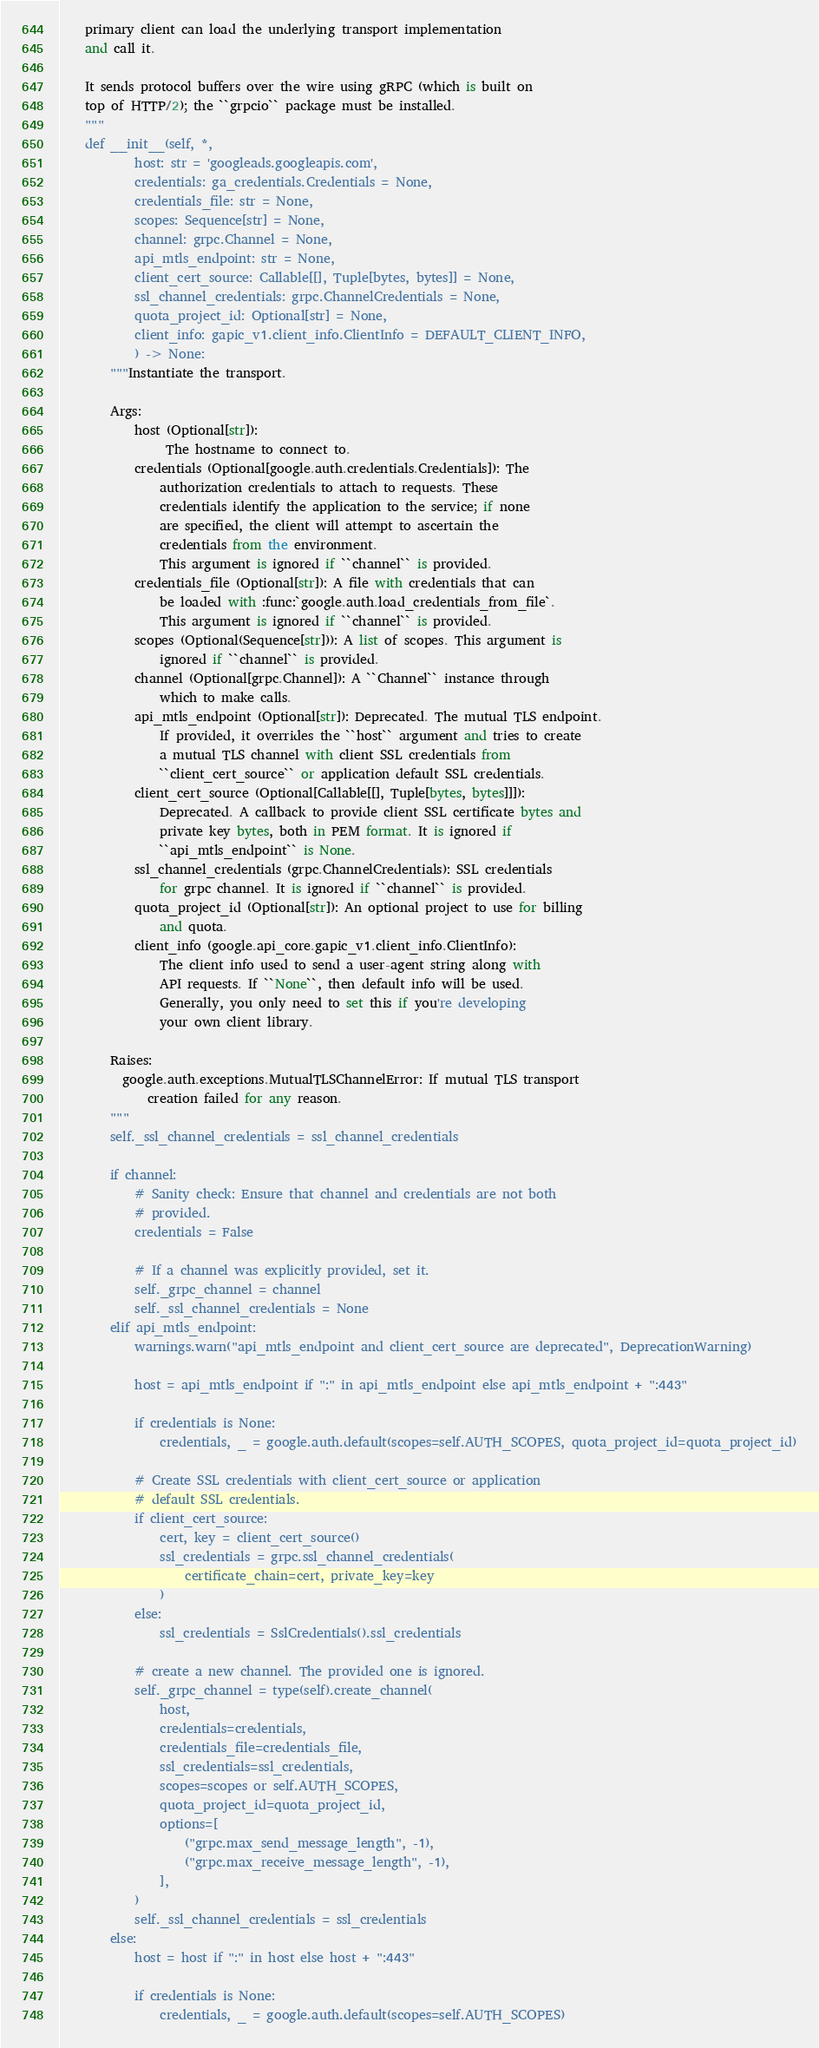Convert code to text. <code><loc_0><loc_0><loc_500><loc_500><_Python_>    primary client can load the underlying transport implementation
    and call it.

    It sends protocol buffers over the wire using gRPC (which is built on
    top of HTTP/2); the ``grpcio`` package must be installed.
    """
    def __init__(self, *,
            host: str = 'googleads.googleapis.com',
            credentials: ga_credentials.Credentials = None,
            credentials_file: str = None,
            scopes: Sequence[str] = None,
            channel: grpc.Channel = None,
            api_mtls_endpoint: str = None,
            client_cert_source: Callable[[], Tuple[bytes, bytes]] = None,
            ssl_channel_credentials: grpc.ChannelCredentials = None,
            quota_project_id: Optional[str] = None,
            client_info: gapic_v1.client_info.ClientInfo = DEFAULT_CLIENT_INFO,
            ) -> None:
        """Instantiate the transport.

        Args:
            host (Optional[str]):
                 The hostname to connect to.
            credentials (Optional[google.auth.credentials.Credentials]): The
                authorization credentials to attach to requests. These
                credentials identify the application to the service; if none
                are specified, the client will attempt to ascertain the
                credentials from the environment.
                This argument is ignored if ``channel`` is provided.
            credentials_file (Optional[str]): A file with credentials that can
                be loaded with :func:`google.auth.load_credentials_from_file`.
                This argument is ignored if ``channel`` is provided.
            scopes (Optional(Sequence[str])): A list of scopes. This argument is
                ignored if ``channel`` is provided.
            channel (Optional[grpc.Channel]): A ``Channel`` instance through
                which to make calls.
            api_mtls_endpoint (Optional[str]): Deprecated. The mutual TLS endpoint.
                If provided, it overrides the ``host`` argument and tries to create
                a mutual TLS channel with client SSL credentials from
                ``client_cert_source`` or application default SSL credentials.
            client_cert_source (Optional[Callable[[], Tuple[bytes, bytes]]]):
                Deprecated. A callback to provide client SSL certificate bytes and
                private key bytes, both in PEM format. It is ignored if
                ``api_mtls_endpoint`` is None.
            ssl_channel_credentials (grpc.ChannelCredentials): SSL credentials
                for grpc channel. It is ignored if ``channel`` is provided.
            quota_project_id (Optional[str]): An optional project to use for billing
                and quota.
            client_info (google.api_core.gapic_v1.client_info.ClientInfo):
                The client info used to send a user-agent string along with
                API requests. If ``None``, then default info will be used.
                Generally, you only need to set this if you're developing
                your own client library.

        Raises:
          google.auth.exceptions.MutualTLSChannelError: If mutual TLS transport
              creation failed for any reason.
        """
        self._ssl_channel_credentials = ssl_channel_credentials

        if channel:
            # Sanity check: Ensure that channel and credentials are not both
            # provided.
            credentials = False

            # If a channel was explicitly provided, set it.
            self._grpc_channel = channel
            self._ssl_channel_credentials = None
        elif api_mtls_endpoint:
            warnings.warn("api_mtls_endpoint and client_cert_source are deprecated", DeprecationWarning)

            host = api_mtls_endpoint if ":" in api_mtls_endpoint else api_mtls_endpoint + ":443"

            if credentials is None:
                credentials, _ = google.auth.default(scopes=self.AUTH_SCOPES, quota_project_id=quota_project_id)

            # Create SSL credentials with client_cert_source or application
            # default SSL credentials.
            if client_cert_source:
                cert, key = client_cert_source()
                ssl_credentials = grpc.ssl_channel_credentials(
                    certificate_chain=cert, private_key=key
                )
            else:
                ssl_credentials = SslCredentials().ssl_credentials

            # create a new channel. The provided one is ignored.
            self._grpc_channel = type(self).create_channel(
                host,
                credentials=credentials,
                credentials_file=credentials_file,
                ssl_credentials=ssl_credentials,
                scopes=scopes or self.AUTH_SCOPES,
                quota_project_id=quota_project_id,
                options=[
                    ("grpc.max_send_message_length", -1),
                    ("grpc.max_receive_message_length", -1),
                ],
            )
            self._ssl_channel_credentials = ssl_credentials
        else:
            host = host if ":" in host else host + ":443"

            if credentials is None:
                credentials, _ = google.auth.default(scopes=self.AUTH_SCOPES)
</code> 